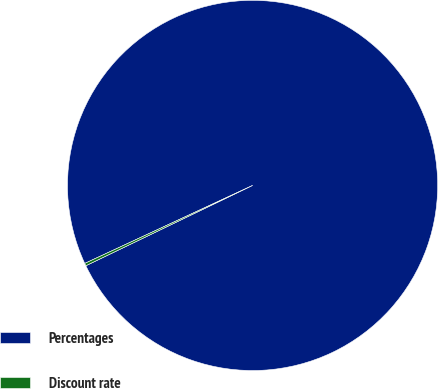Convert chart to OTSL. <chart><loc_0><loc_0><loc_500><loc_500><pie_chart><fcel>Percentages<fcel>Discount rate<nl><fcel>99.78%<fcel>0.22%<nl></chart> 